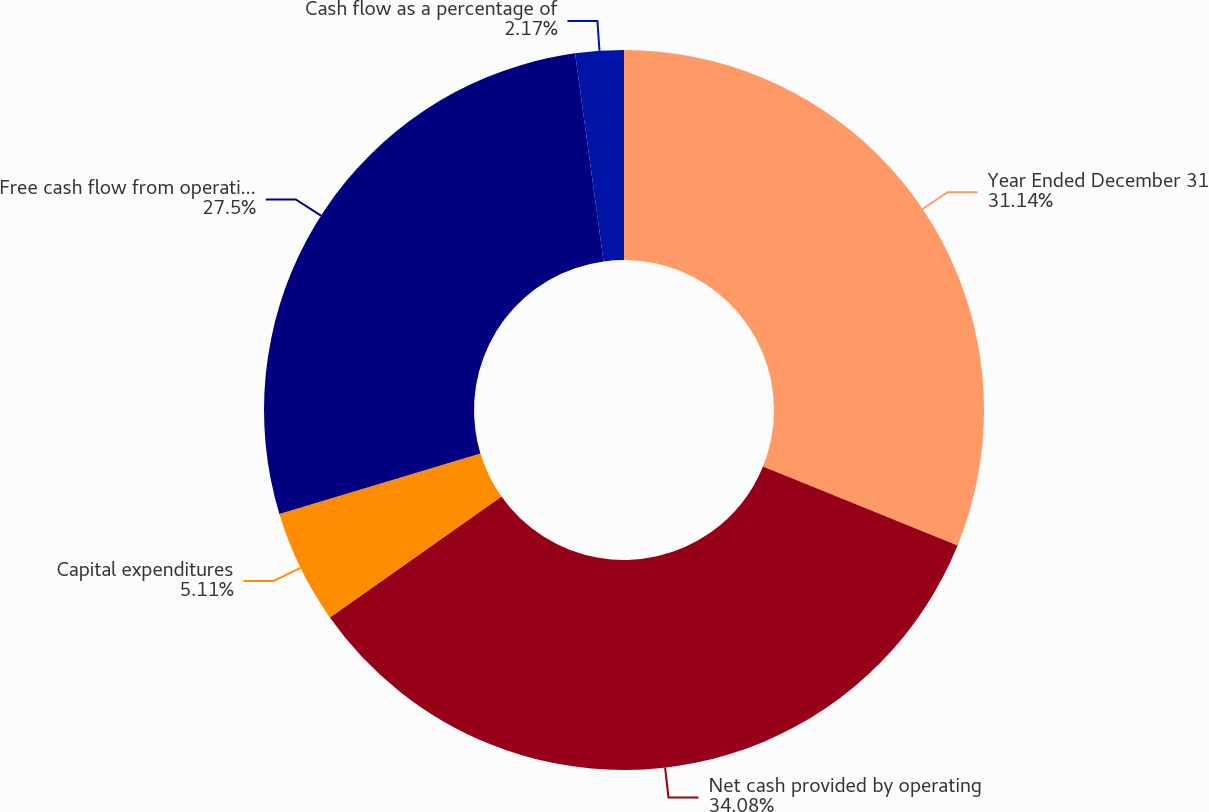Convert chart to OTSL. <chart><loc_0><loc_0><loc_500><loc_500><pie_chart><fcel>Year Ended December 31<fcel>Net cash provided by operating<fcel>Capital expenditures<fcel>Free cash flow from operations<fcel>Cash flow as a percentage of<nl><fcel>31.14%<fcel>34.08%<fcel>5.11%<fcel>27.5%<fcel>2.17%<nl></chart> 